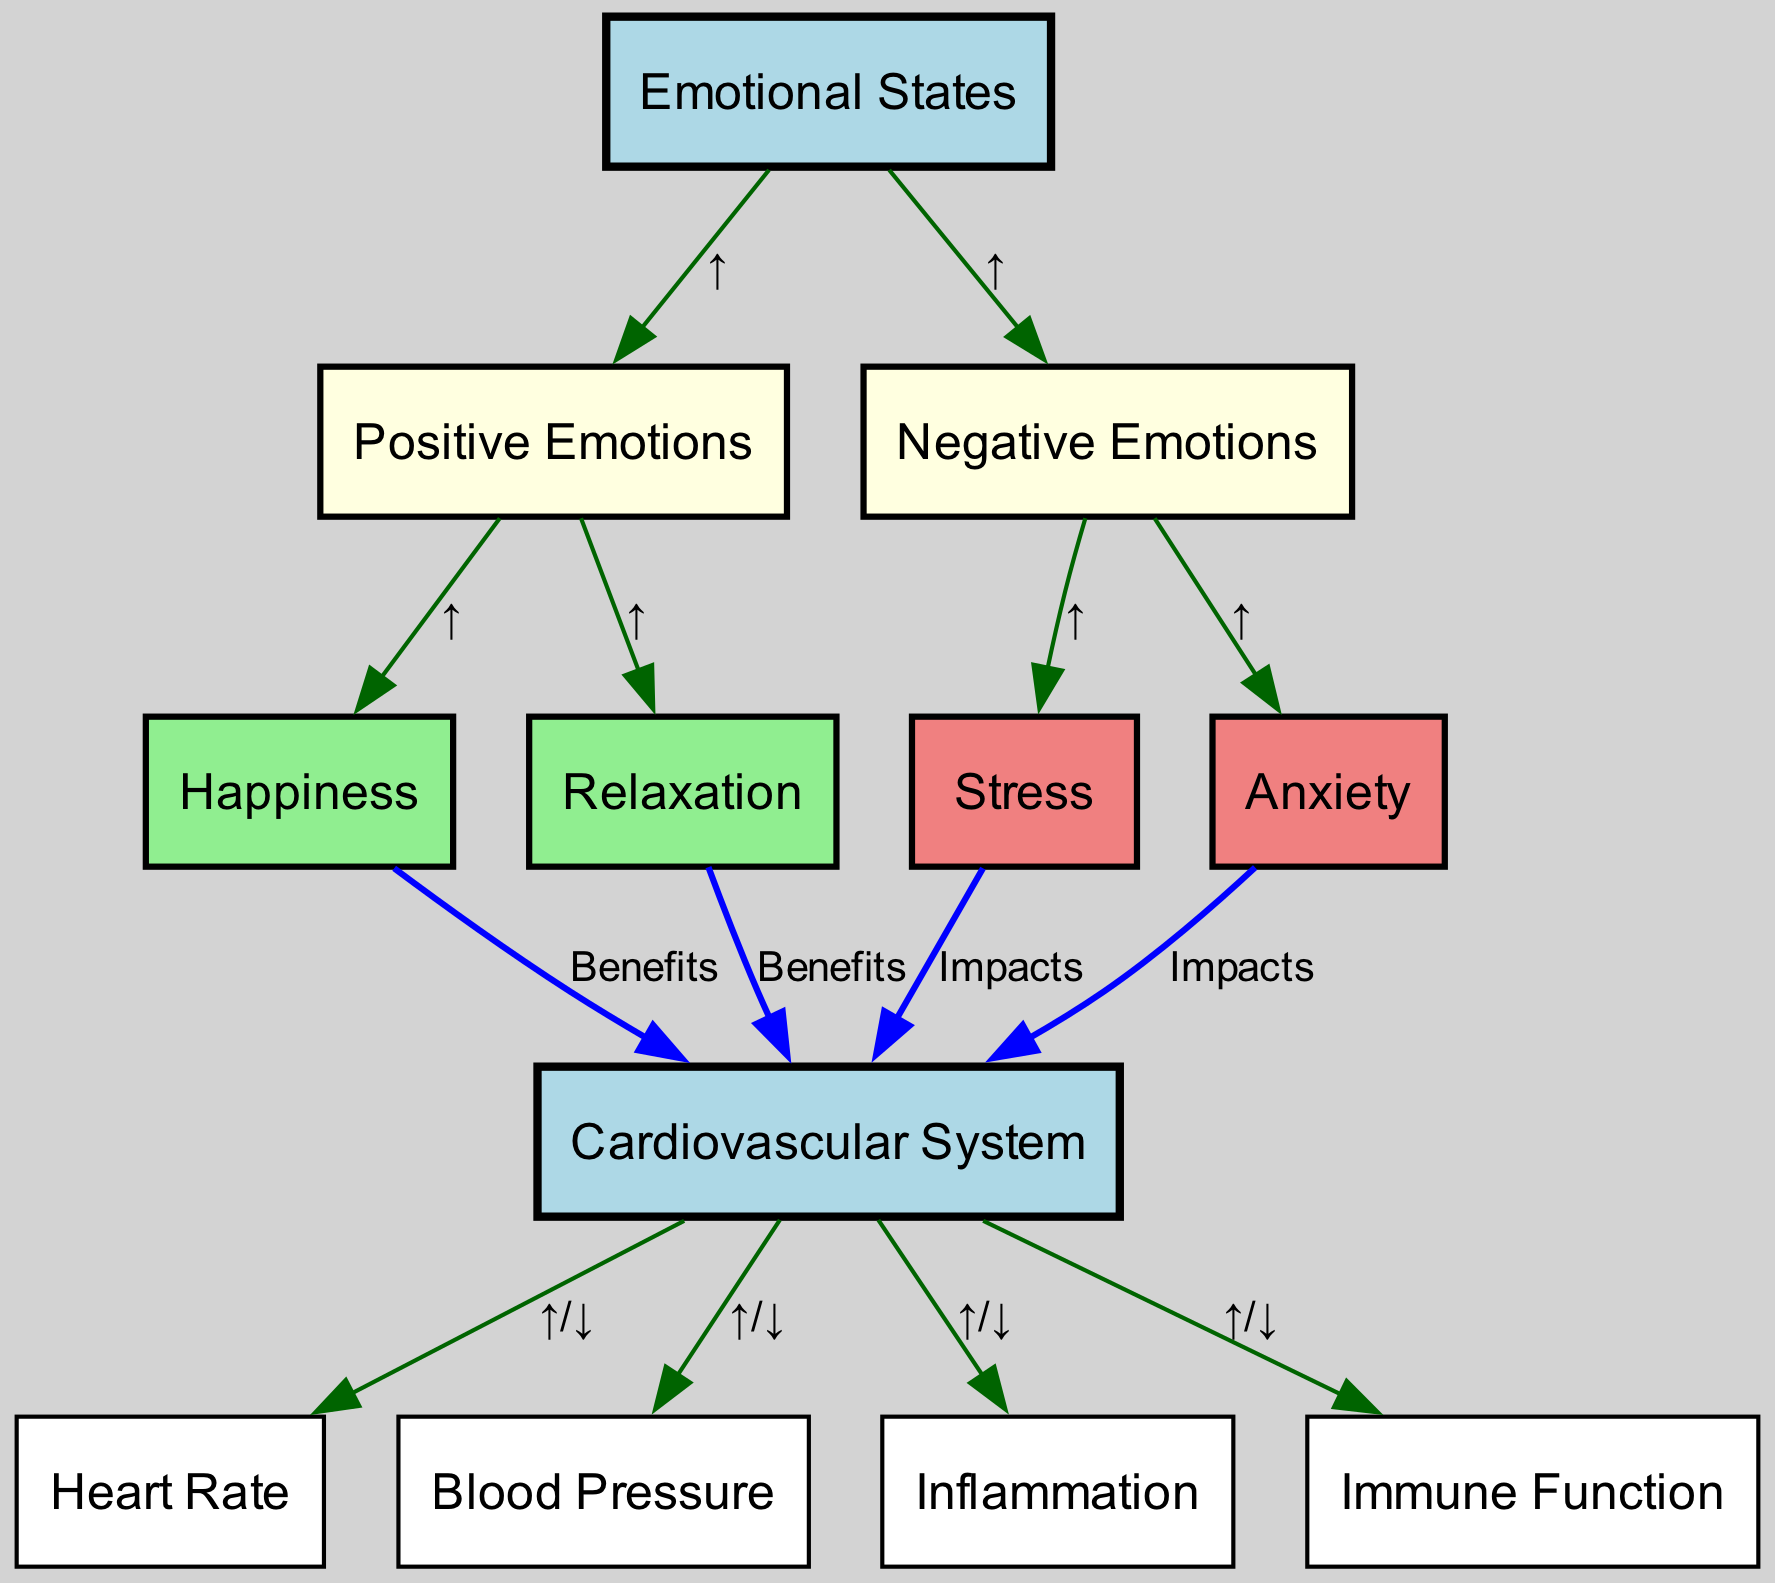What are the two main categories of emotional states depicted in the diagram? The diagram illustrates two primary categories of emotional states: positive emotions and negative emotions, as indicated by the nodes connected to the main emotions node.
Answer: Positive emotions and negative emotions Which two emotional states are linked to stress? Examining the edges leading from negative emotions, the diagram shows that both stress and anxiety are directly connected to negative emotions, meaning they both result from these emotional states.
Answer: Stress and anxiety What is the relationship between happiness and the cardiovascular system? The diagram indicates a beneficial relationship between happiness and the cardiovascular system. The edge labeled "Benefits" shows that happiness positively influences the cardiovascular system.
Answer: Benefits How does anxiety affect the cardiovascular system? According to the diagram, anxiety has a negative impact on the cardiovascular system, which is depicted by the edge labeled "Impacts" connecting anxiety to the cardiovascular system.
Answer: Impacts What are the effects of relaxation on heart rate, blood pressure, inflammation, and immune function? The diagram shows that relaxation benefits the cardiovascular system; therefore, it can result in various positive effects on the heart rate, blood pressure, inflammation, and immune function, which can be inferred as improvements or reductions in these factors.
Answer: Benefits How many nodes are associated with emotional states in the diagram? Upon reviewing the nodes related to emotions, we identify a total of six nodes: emotions, positive emotions, negative emotions, stress, anxiety, happiness, and relaxation, resulting in six nodes being linked to emotional states.
Answer: Six What happens to the cardiovascular system when stress increases? The diagram illustrates that stress impacts the cardiovascular system negatively, which implies that higher stress levels can lead to adverse effects on cardiovascular health.
Answer: Impacts How many edges are there connecting emotions to the cardiovascular system? Counting the connections from the emotions node to the cardiovascular system, we find four edges connected to it directly (considering impacts and benefits), which indicates direct relationships depicted in the diagram.
Answer: Four 